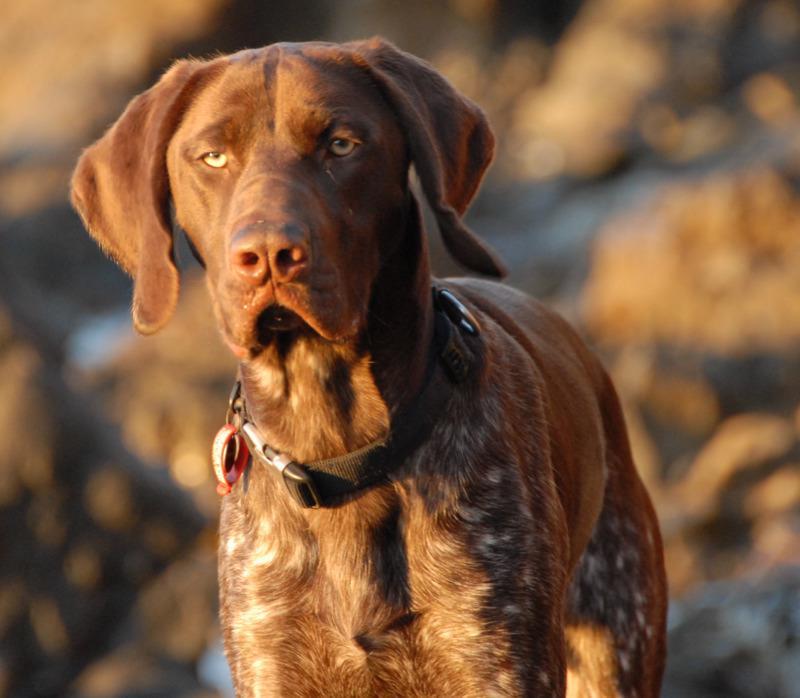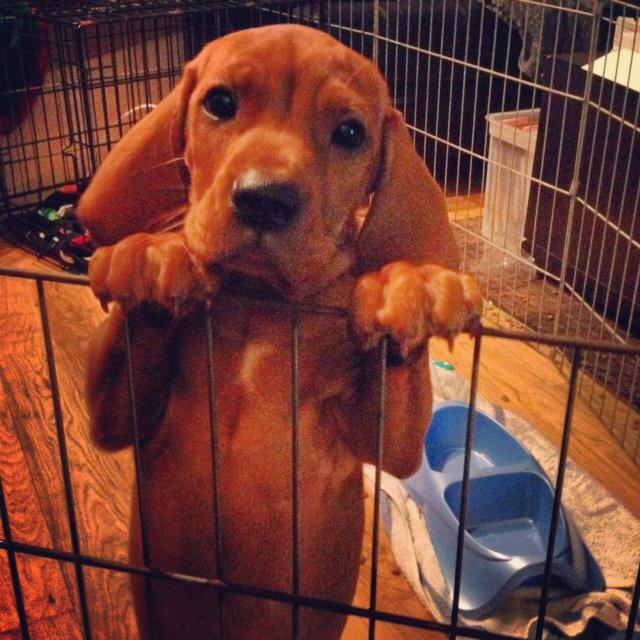The first image is the image on the left, the second image is the image on the right. Given the left and right images, does the statement "The dog in the left image is wearing a collar." hold true? Answer yes or no. Yes. 